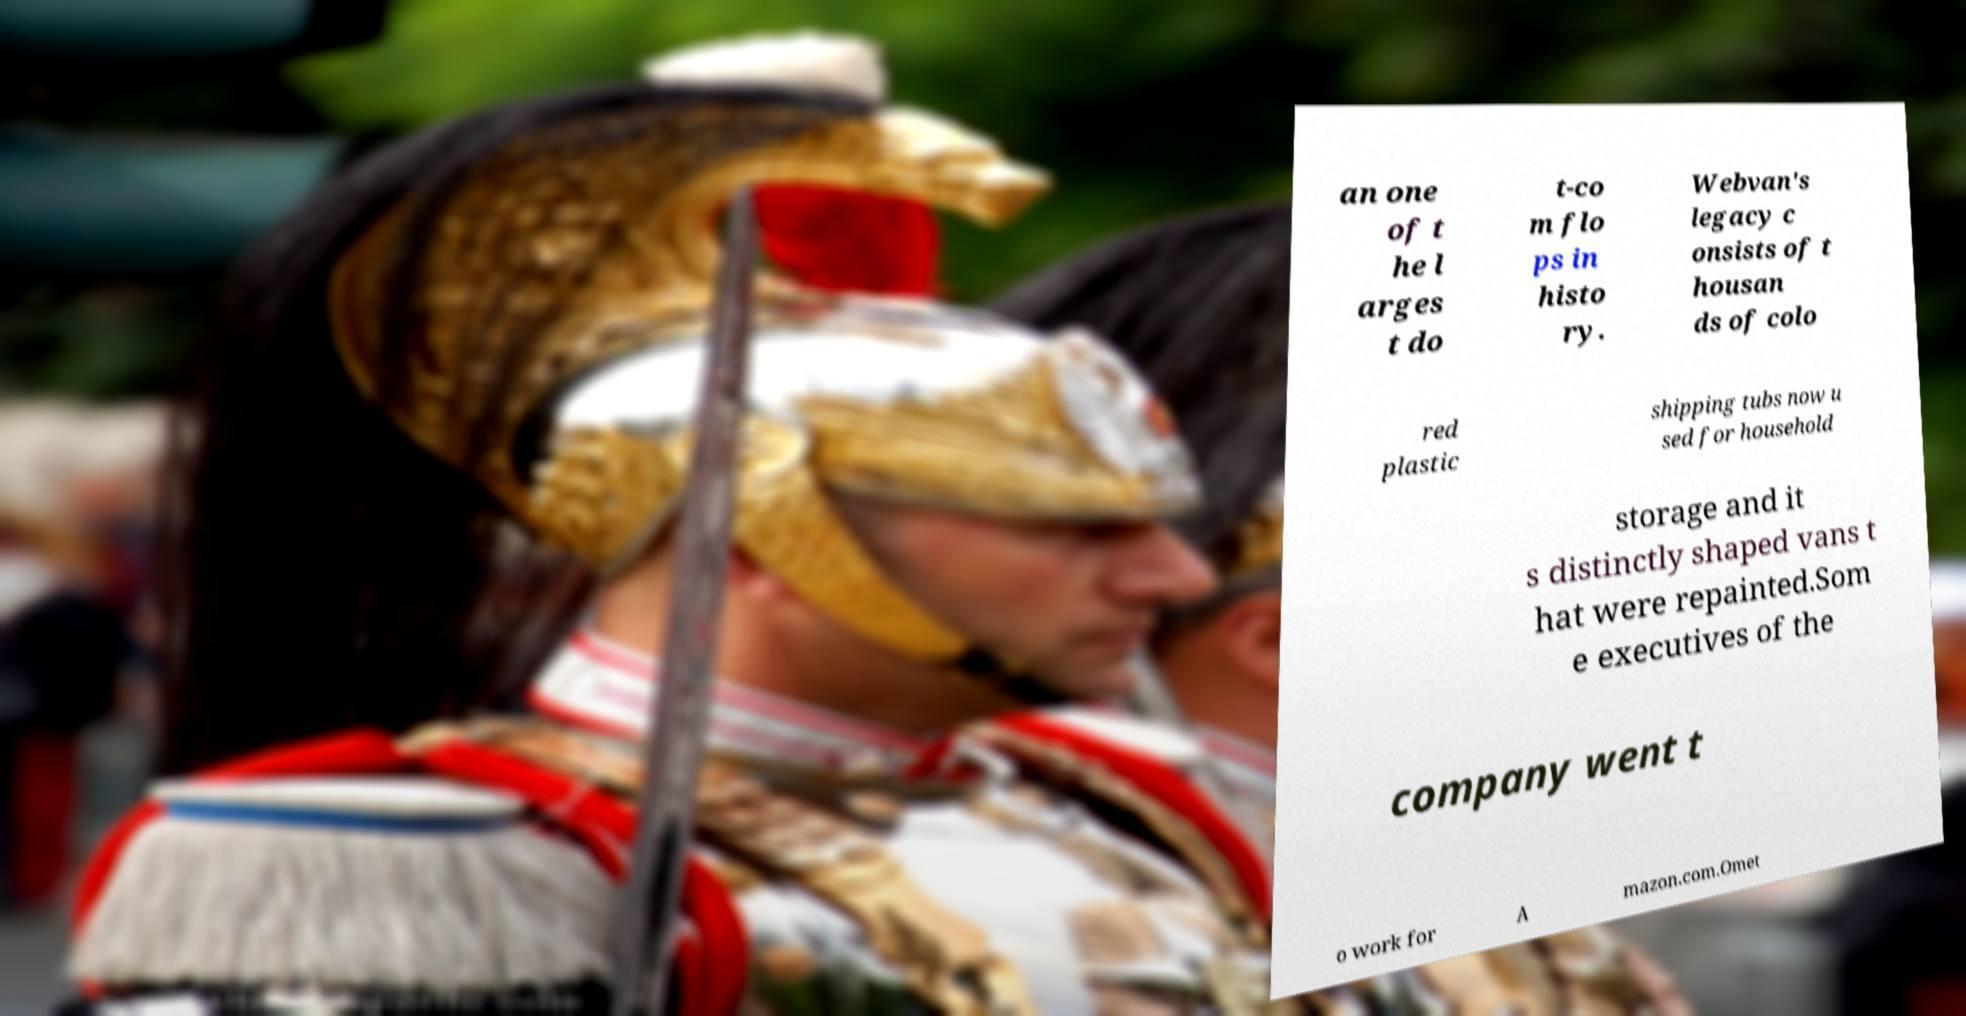There's text embedded in this image that I need extracted. Can you transcribe it verbatim? an one of t he l arges t do t-co m flo ps in histo ry. Webvan's legacy c onsists of t housan ds of colo red plastic shipping tubs now u sed for household storage and it s distinctly shaped vans t hat were repainted.Som e executives of the company went t o work for A mazon.com.Omet 